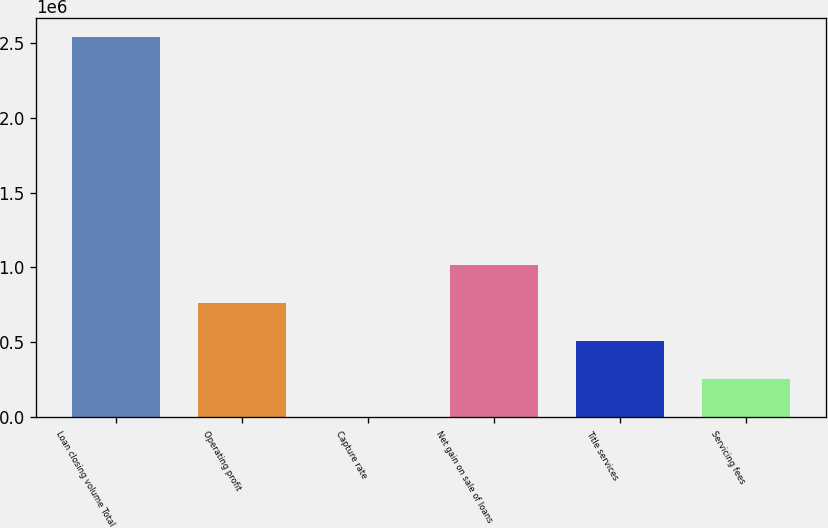Convert chart. <chart><loc_0><loc_0><loc_500><loc_500><bar_chart><fcel>Loan closing volume Total<fcel>Operating profit<fcel>Capture rate<fcel>Net gain on sale of loans<fcel>Title services<fcel>Servicing fees<nl><fcel>2.53807e+06<fcel>761478<fcel>81<fcel>1.01528e+06<fcel>507679<fcel>253880<nl></chart> 